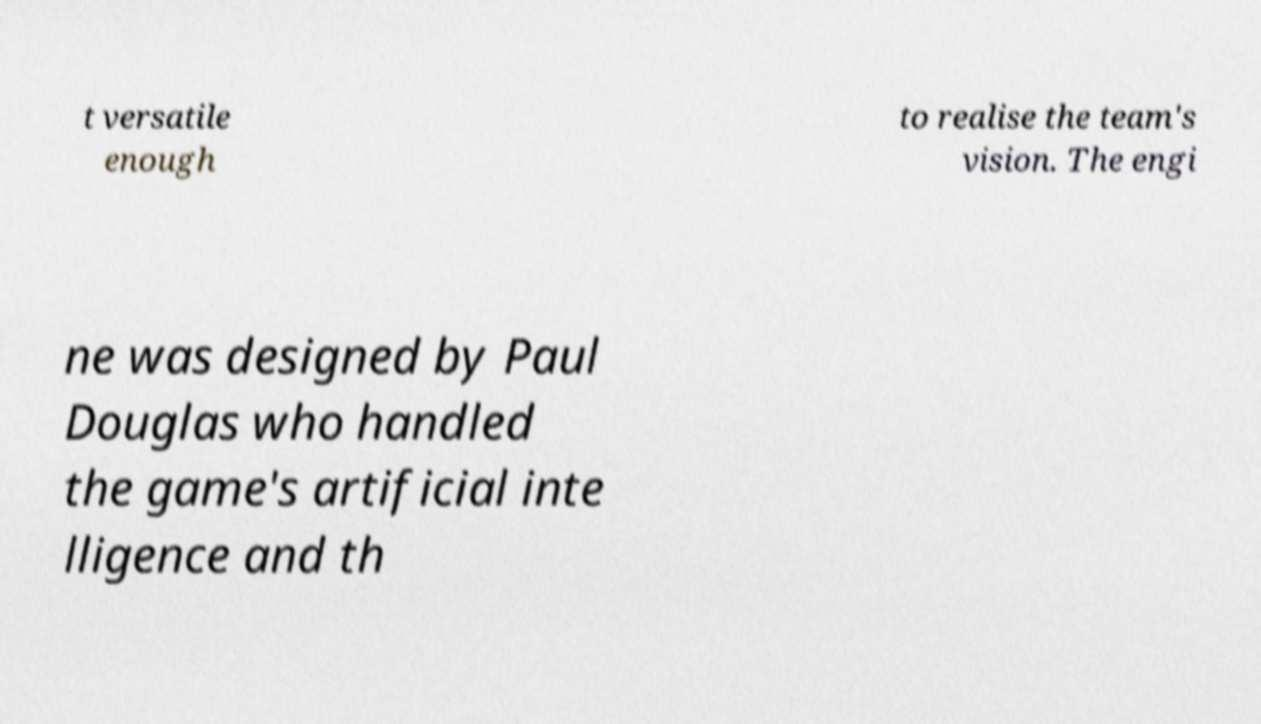There's text embedded in this image that I need extracted. Can you transcribe it verbatim? t versatile enough to realise the team's vision. The engi ne was designed by Paul Douglas who handled the game's artificial inte lligence and th 